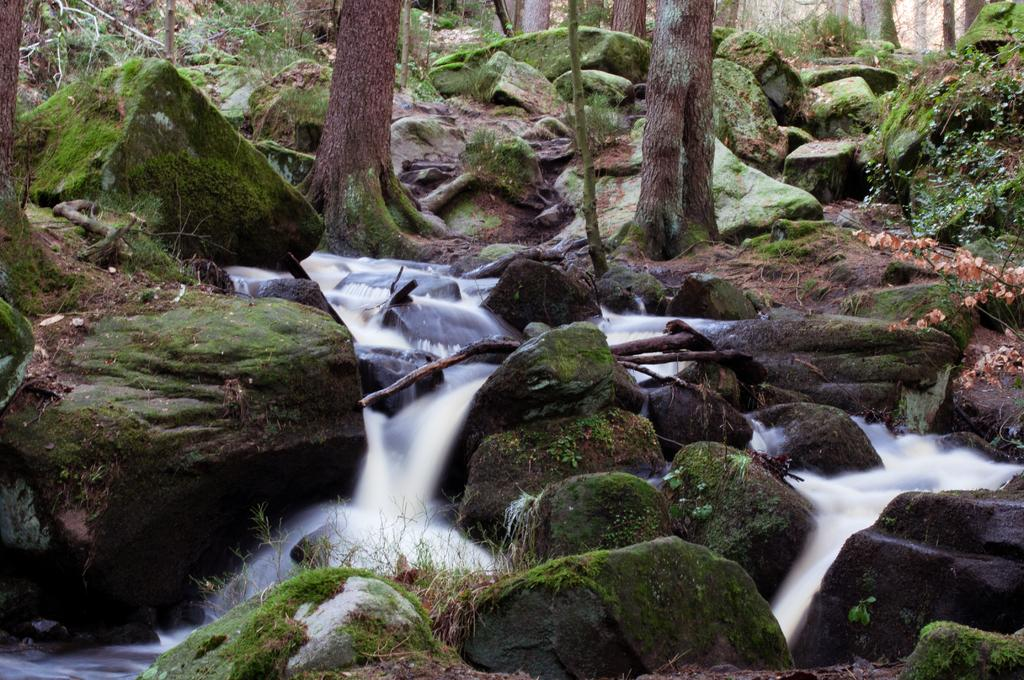What natural feature is located at the bottom of the image? There is a waterfall at the bottom of the image. What can be found at the base of the waterfall? There are rocks at the bottom of the image. What is visible in the background of the image? There are rocks, trees, and grass in the background of the image. What type of cake is being served at the waterfall in the image? There is no cake present in the image; it features a waterfall and surrounding natural elements. 